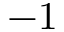<formula> <loc_0><loc_0><loc_500><loc_500>- 1</formula> 